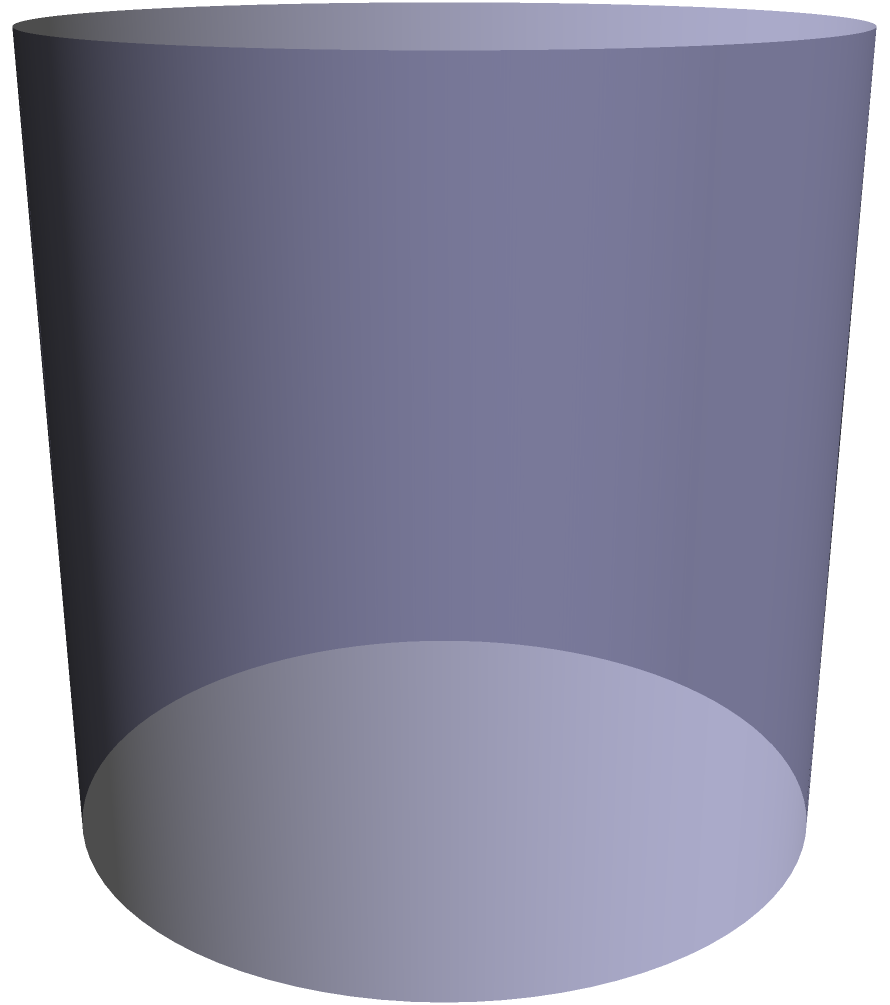At Charter Oak Park, you remember enjoying ice cream sundaes served in unique glass cups. These cups resembled a cylinder with a hemispherical base. If the radius of the cup was 2 inches and the height of the cylindrical part was 4 inches, what was the total volume of the cup in cubic inches? (Use $\pi = 3.14$) Let's break this down step-by-step:

1) The cup consists of two parts: a cylinder and a hemisphere.

2) For the cylinder:
   - Radius ($r$) = 2 inches
   - Height ($h$) = 4 inches
   - Volume of cylinder = $\pi r^2 h$
   - $V_{cylinder} = 3.14 \times 2^2 \times 4 = 3.14 \times 4 \times 4 = 50.24$ cubic inches

3) For the hemisphere:
   - Radius ($r$) = 2 inches
   - Volume of hemisphere = $\frac{2}{3}\pi r^3$
   - $V_{hemisphere} = \frac{2}{3} \times 3.14 \times 2^3 = \frac{2}{3} \times 3.14 \times 8 = 16.75$ cubic inches

4) Total volume:
   $V_{total} = V_{cylinder} + V_{hemisphere}$
   $V_{total} = 50.24 + 16.75 = 66.99$ cubic inches

Therefore, the total volume of the ice cream sundae cup is approximately 66.99 cubic inches.
Answer: 66.99 cubic inches 